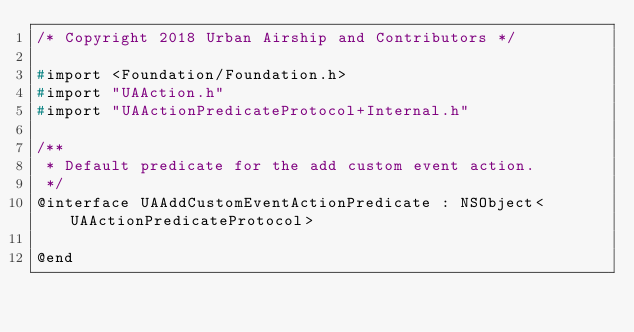<code> <loc_0><loc_0><loc_500><loc_500><_C_>/* Copyright 2018 Urban Airship and Contributors */

#import <Foundation/Foundation.h>
#import "UAAction.h"
#import "UAActionPredicateProtocol+Internal.h"

/**
 * Default predicate for the add custom event action.
 */
@interface UAAddCustomEventActionPredicate : NSObject<UAActionPredicateProtocol>

@end
</code> 